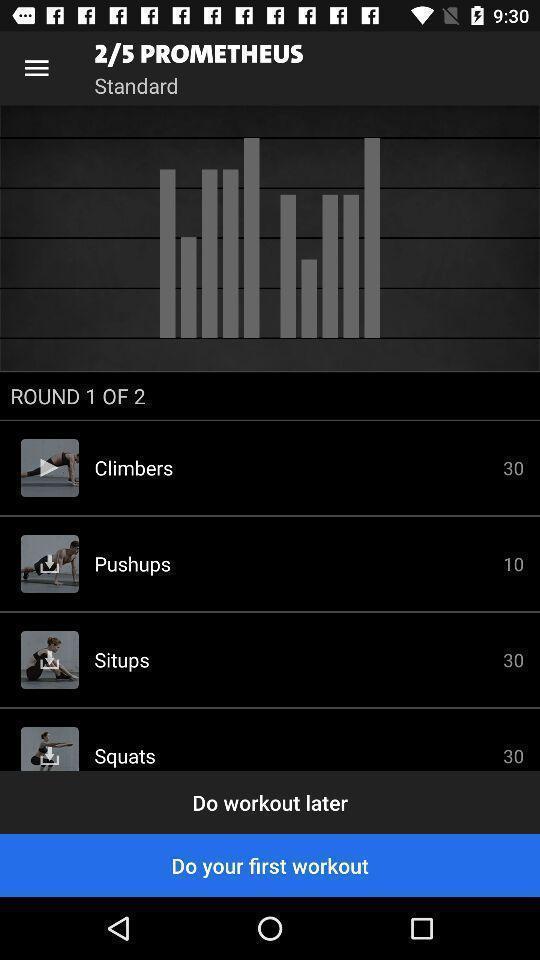Summarize the information in this screenshot. Screen shows types of workouts. 